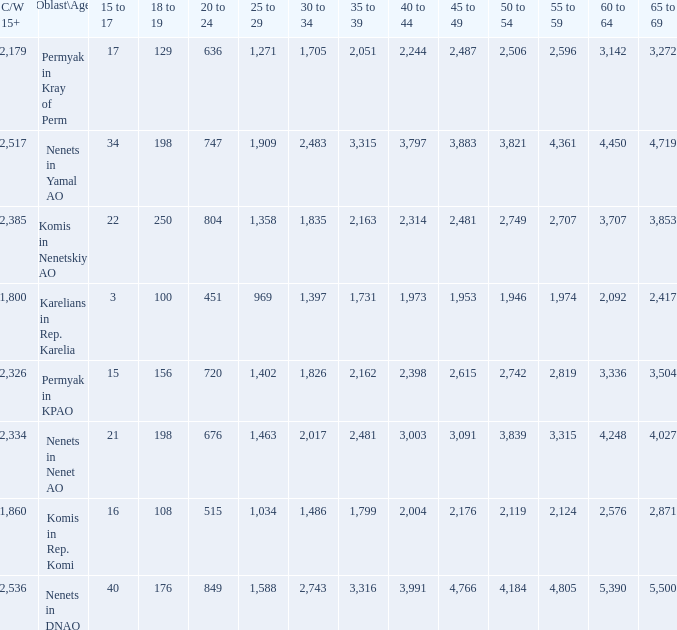What is the total 60 to 64 when the Oblast\Age is Nenets in Yamal AO, and the 45 to 49 is bigger than 3,883? None. 